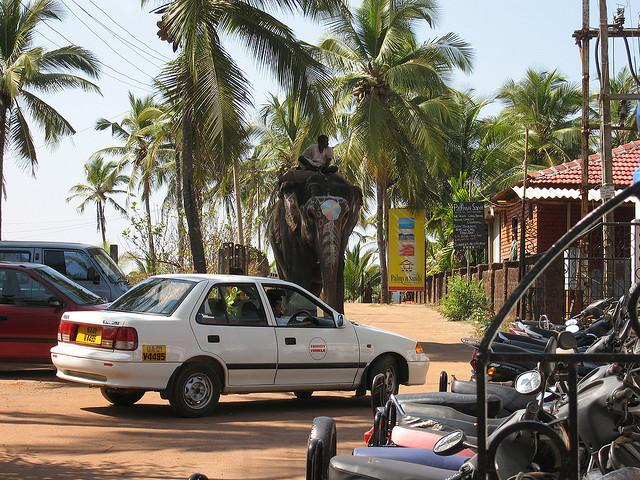What is this place? Please explain your reasoning. biker bar. There is a large row of motorcycles parked out front. when there are this many motorcycles parked out front of a location it is frequently a place that caters to their owners. 